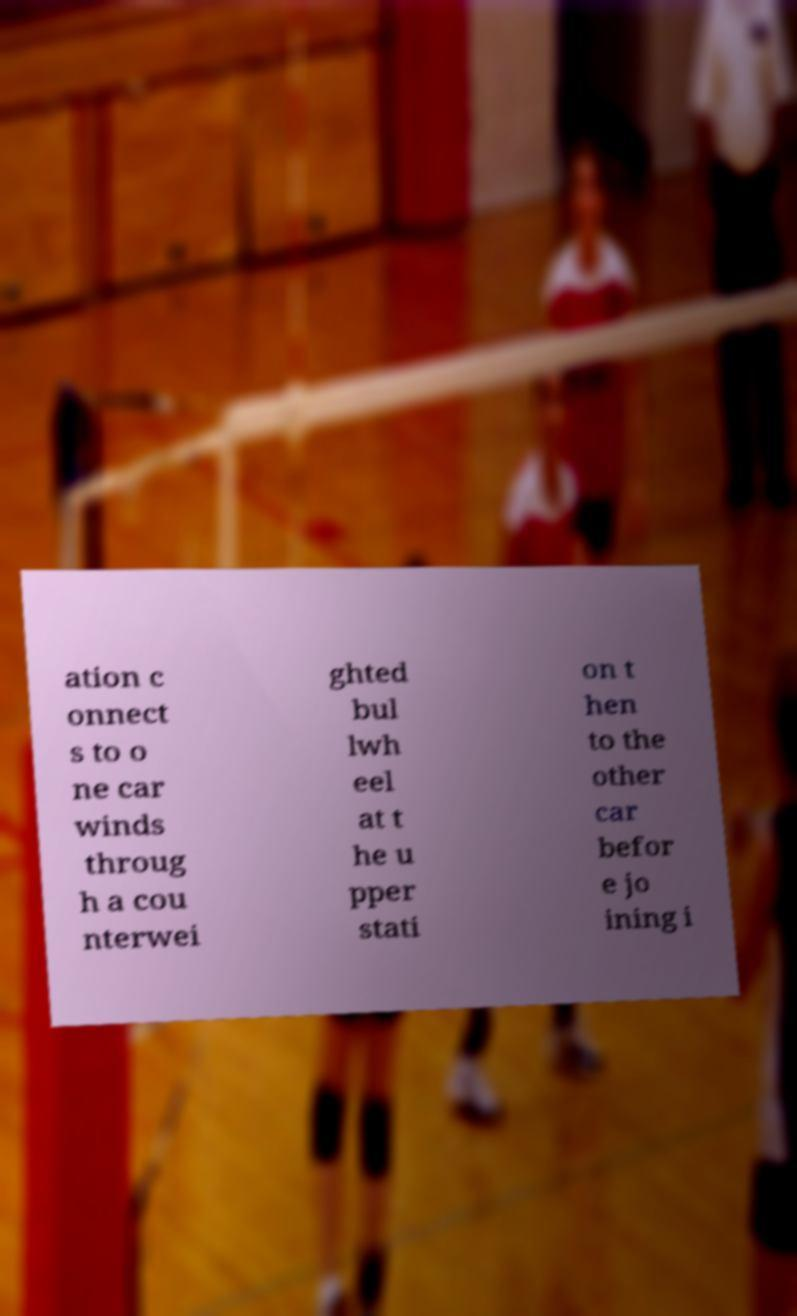Can you read and provide the text displayed in the image?This photo seems to have some interesting text. Can you extract and type it out for me? ation c onnect s to o ne car winds throug h a cou nterwei ghted bul lwh eel at t he u pper stati on t hen to the other car befor e jo ining i 